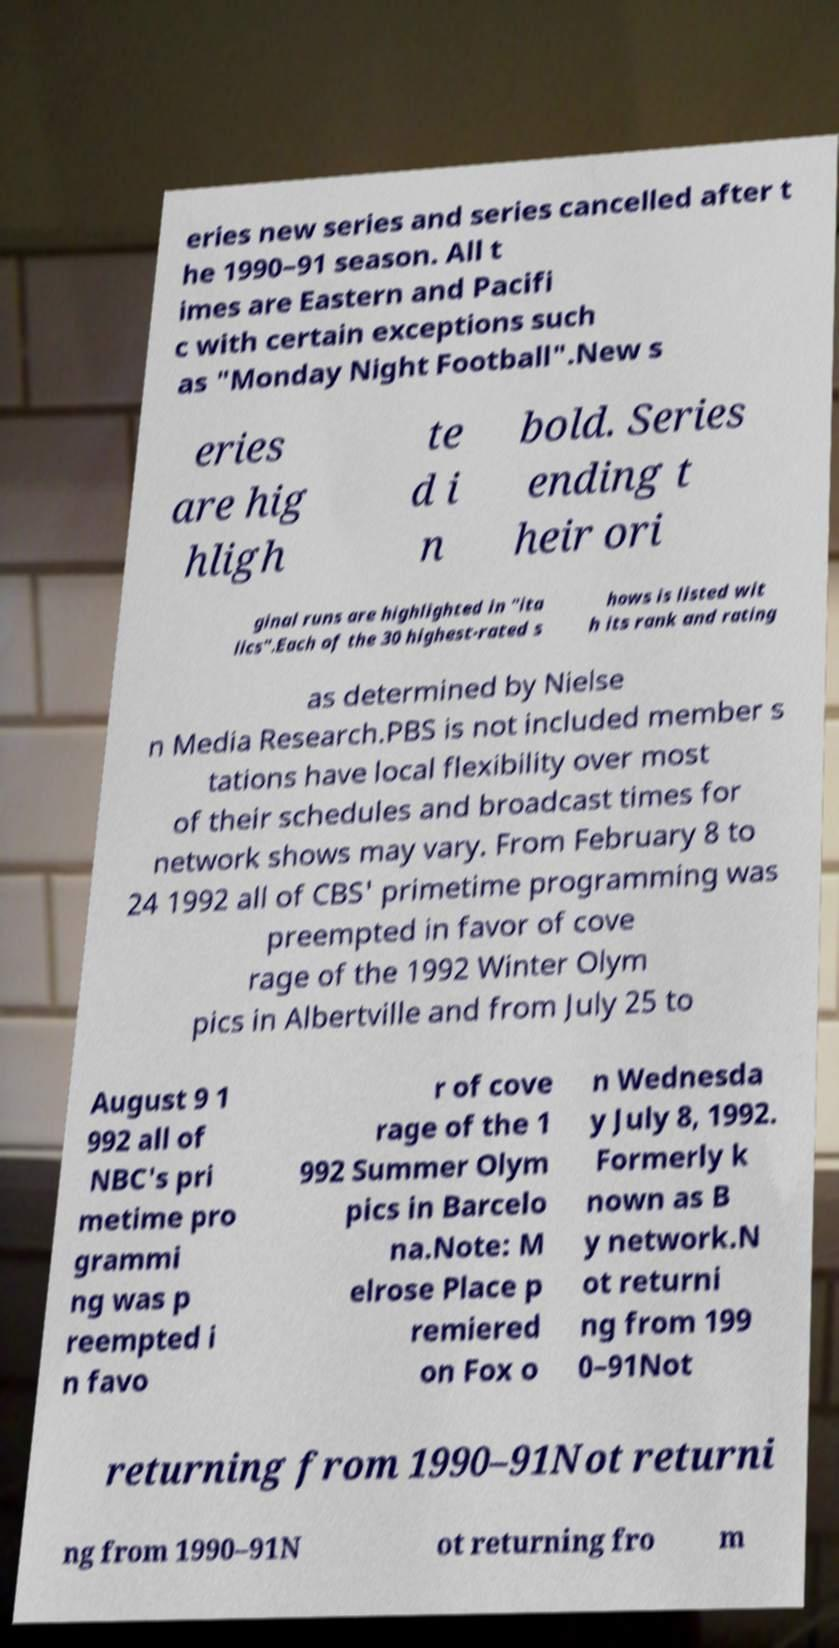Could you assist in decoding the text presented in this image and type it out clearly? eries new series and series cancelled after t he 1990–91 season. All t imes are Eastern and Pacifi c with certain exceptions such as "Monday Night Football".New s eries are hig hligh te d i n bold. Series ending t heir ori ginal runs are highlighted in "ita lics".Each of the 30 highest-rated s hows is listed wit h its rank and rating as determined by Nielse n Media Research.PBS is not included member s tations have local flexibility over most of their schedules and broadcast times for network shows may vary. From February 8 to 24 1992 all of CBS' primetime programming was preempted in favor of cove rage of the 1992 Winter Olym pics in Albertville and from July 25 to August 9 1 992 all of NBC's pri metime pro grammi ng was p reempted i n favo r of cove rage of the 1 992 Summer Olym pics in Barcelo na.Note: M elrose Place p remiered on Fox o n Wednesda y July 8, 1992. Formerly k nown as B y network.N ot returni ng from 199 0–91Not returning from 1990–91Not returni ng from 1990–91N ot returning fro m 